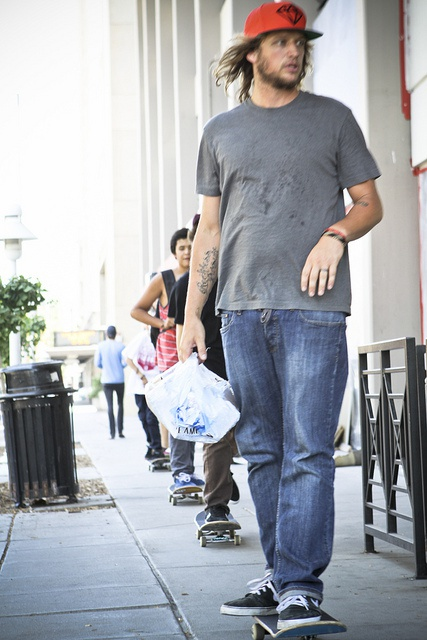Describe the objects in this image and their specific colors. I can see people in lightgray, gray, and darkgray tones, people in lightgray, black, gray, and darkgray tones, people in lightgray, black, gray, and tan tones, people in lightgray, lavender, black, and gray tones, and skateboard in lightgray, navy, black, gray, and darkgray tones in this image. 